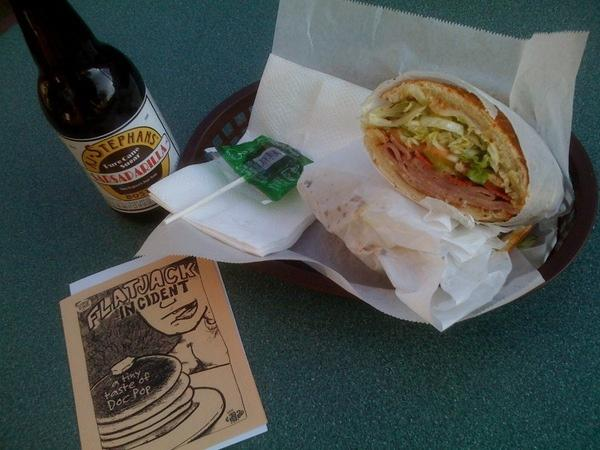This beverage tastes similar to what other beverage? Please explain your reasoning. root beer. Root beer is a soda beverage that has a similar flavor to sasparilla. 